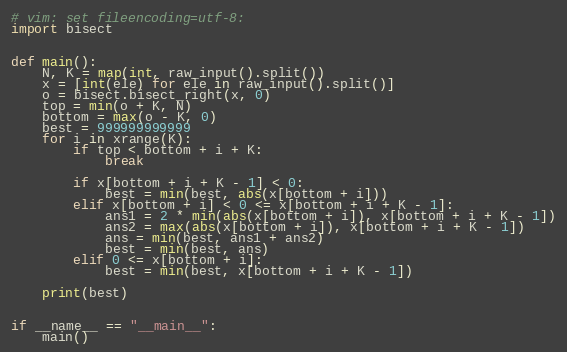<code> <loc_0><loc_0><loc_500><loc_500><_Python_># vim: set fileencoding=utf-8:
import bisect


def main():
    N, K = map(int, raw_input().split())
    x = [int(ele) for ele in raw_input().split()]
    o = bisect.bisect_right(x, 0)
    top = min(o + K, N)
    bottom = max(o - K, 0)
    best = 999999999999
    for i in xrange(K):
        if top < bottom + i + K:
            break

        if x[bottom + i + K - 1] < 0:
            best = min(best, abs(x[bottom + i]))
        elif x[bottom + i] < 0 <= x[bottom + i + K - 1]:
            ans1 = 2 * min(abs(x[bottom + i]), x[bottom + i + K - 1])
            ans2 = max(abs(x[bottom + i]), x[bottom + i + K - 1])
            ans = min(best, ans1 + ans2)
            best = min(best, ans)
        elif 0 <= x[bottom + i]:
            best = min(best, x[bottom + i + K - 1])

    print(best)


if __name__ == "__main__":
    main()
</code> 